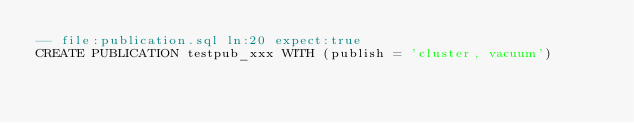Convert code to text. <code><loc_0><loc_0><loc_500><loc_500><_SQL_>-- file:publication.sql ln:20 expect:true
CREATE PUBLICATION testpub_xxx WITH (publish = 'cluster, vacuum')
</code> 